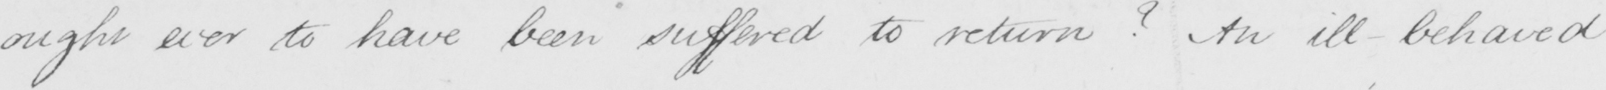Please provide the text content of this handwritten line. ought ever to have been suffered to return ?  An ill behaved 